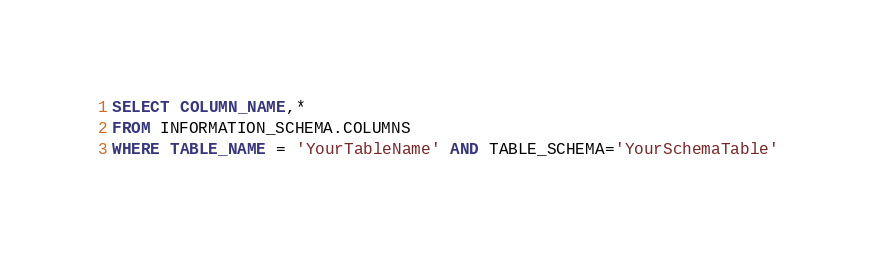Convert code to text. <code><loc_0><loc_0><loc_500><loc_500><_SQL_>SELECT COLUMN_NAME,* 
FROM INFORMATION_SCHEMA.COLUMNS
WHERE TABLE_NAME = 'YourTableName' AND TABLE_SCHEMA='YourSchemaTable'</code> 